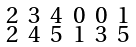<formula> <loc_0><loc_0><loc_500><loc_500>\begin{smallmatrix} 2 & 3 & 4 & 0 & 0 & 1 \\ 2 & 4 & 5 & 1 & 3 & 5 \end{smallmatrix}</formula> 